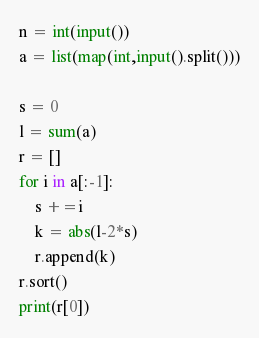Convert code to text. <code><loc_0><loc_0><loc_500><loc_500><_Python_>n = int(input())
a = list(map(int,input().split()))

s = 0
l = sum(a)
r = []
for i in a[:-1]:
    s +=i
    k = abs(l-2*s)
    r.append(k)
r.sort()
print(r[0])</code> 